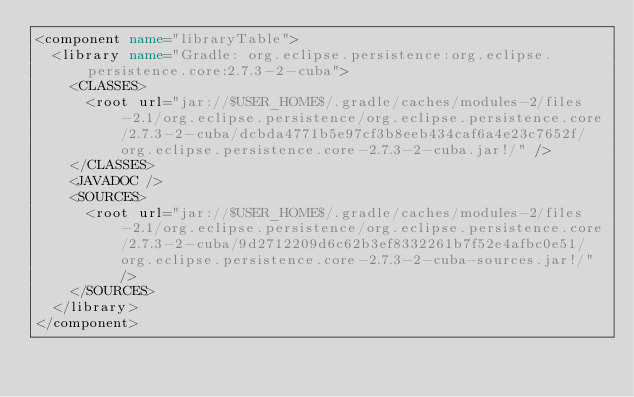Convert code to text. <code><loc_0><loc_0><loc_500><loc_500><_XML_><component name="libraryTable">
  <library name="Gradle: org.eclipse.persistence:org.eclipse.persistence.core:2.7.3-2-cuba">
    <CLASSES>
      <root url="jar://$USER_HOME$/.gradle/caches/modules-2/files-2.1/org.eclipse.persistence/org.eclipse.persistence.core/2.7.3-2-cuba/dcbda4771b5e97cf3b8eeb434caf6a4e23c7652f/org.eclipse.persistence.core-2.7.3-2-cuba.jar!/" />
    </CLASSES>
    <JAVADOC />
    <SOURCES>
      <root url="jar://$USER_HOME$/.gradle/caches/modules-2/files-2.1/org.eclipse.persistence/org.eclipse.persistence.core/2.7.3-2-cuba/9d2712209d6c62b3ef8332261b7f52e4afbc0e51/org.eclipse.persistence.core-2.7.3-2-cuba-sources.jar!/" />
    </SOURCES>
  </library>
</component></code> 